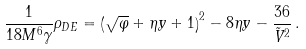<formula> <loc_0><loc_0><loc_500><loc_500>\frac { 1 } { 1 8 M ^ { 6 } \gamma } \rho _ { D E } = \left ( \sqrt { \varphi } + \eta y + 1 \right ) ^ { 2 } - 8 \eta y - \frac { 3 6 } { \tilde { V } ^ { 2 } } \, .</formula> 